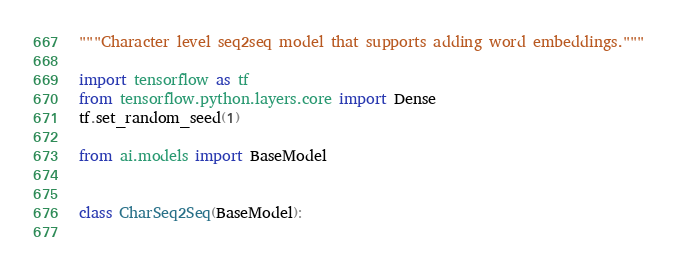<code> <loc_0><loc_0><loc_500><loc_500><_Python_>"""Character level seq2seq model that supports adding word embeddings."""

import tensorflow as tf
from tensorflow.python.layers.core import Dense
tf.set_random_seed(1)

from ai.models import BaseModel


class CharSeq2Seq(BaseModel):
  </code> 